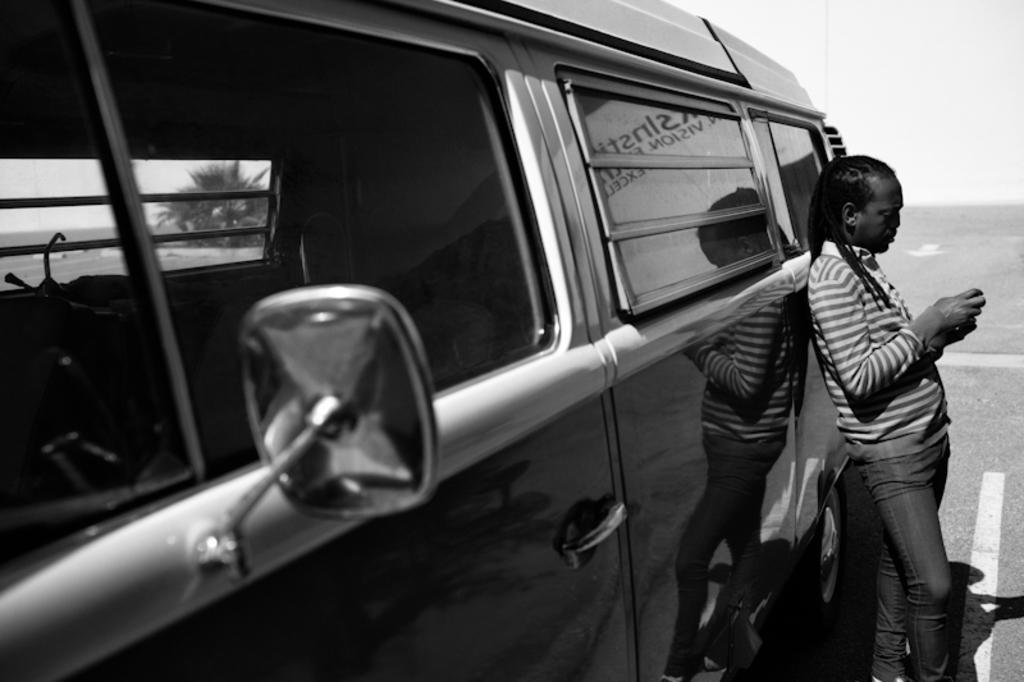In one or two sentences, can you explain what this image depicts? In this black and white image there is a person standing, behind the person there is a vehicle on the road, from the window of the vehicle we can see there is a tree. 